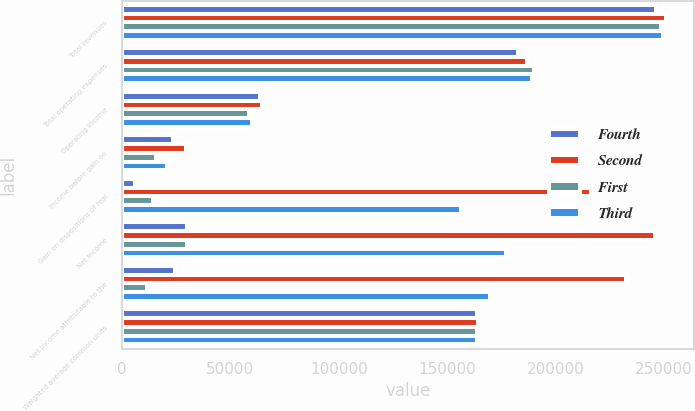<chart> <loc_0><loc_0><loc_500><loc_500><stacked_bar_chart><ecel><fcel>Total revenues<fcel>Total operating expenses<fcel>Operating income<fcel>Income before gain on<fcel>Gain on dispositions of real<fcel>Net income<fcel>Net income attributable to the<fcel>Weighted average common units<nl><fcel>Fourth<fcel>246239<fcel>182705<fcel>63534<fcel>23698<fcel>6187<fcel>29885<fcel>24395<fcel>163639<nl><fcel>Second<fcel>251218<fcel>186782<fcel>64436<fcel>29412<fcel>216541<fcel>245953<fcel>232517<fcel>164188<nl><fcel>First<fcel>248904<fcel>190172<fcel>58732<fcel>15538<fcel>14498<fcel>30036<fcel>11368<fcel>163832<nl><fcel>Third<fcel>249493<fcel>189399<fcel>60094<fcel>20835<fcel>156564<fcel>177399<fcel>169869<fcel>163799<nl></chart> 